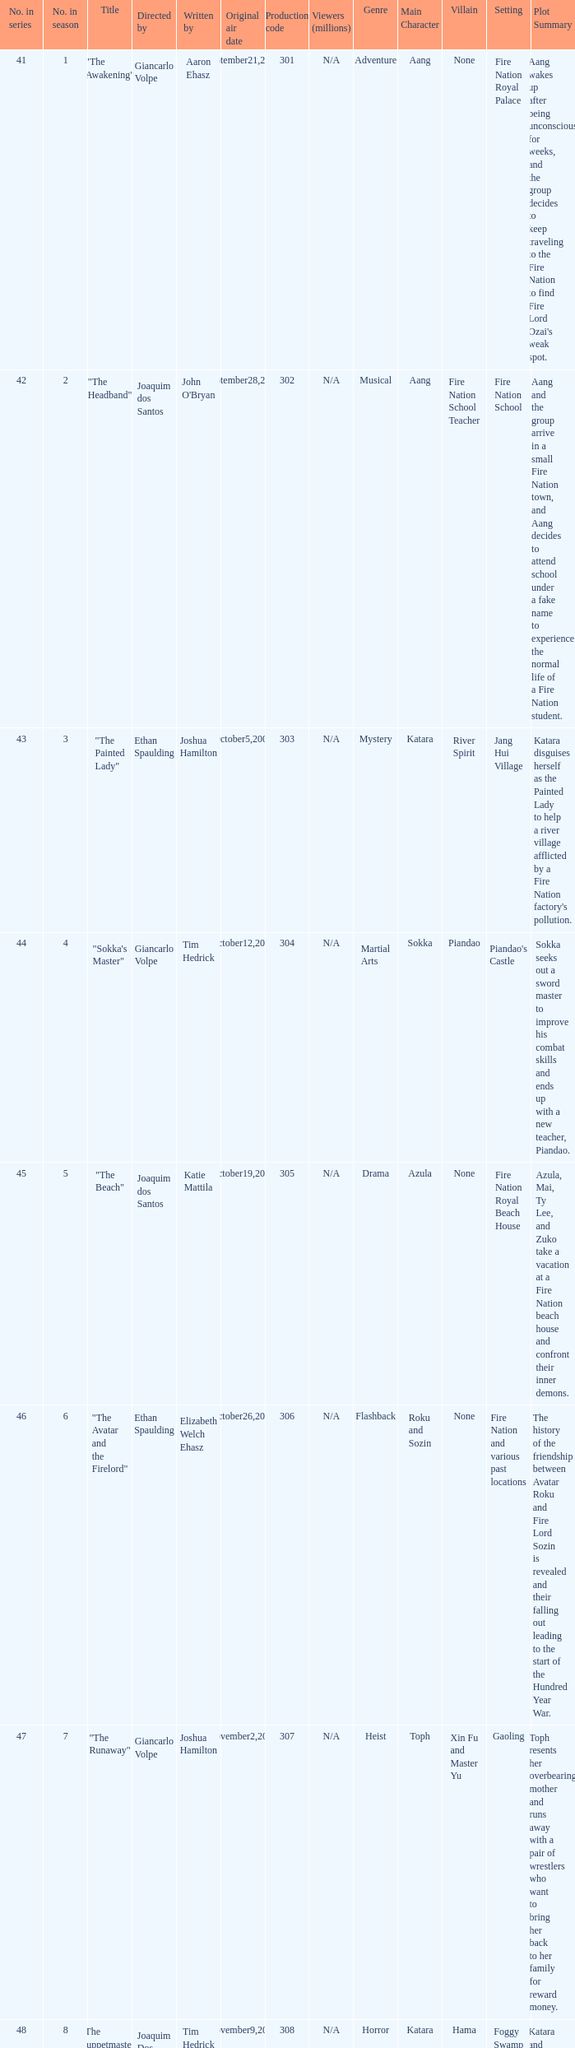What season has an episode written by john o'bryan and directed by ethan spaulding? 9.0. 